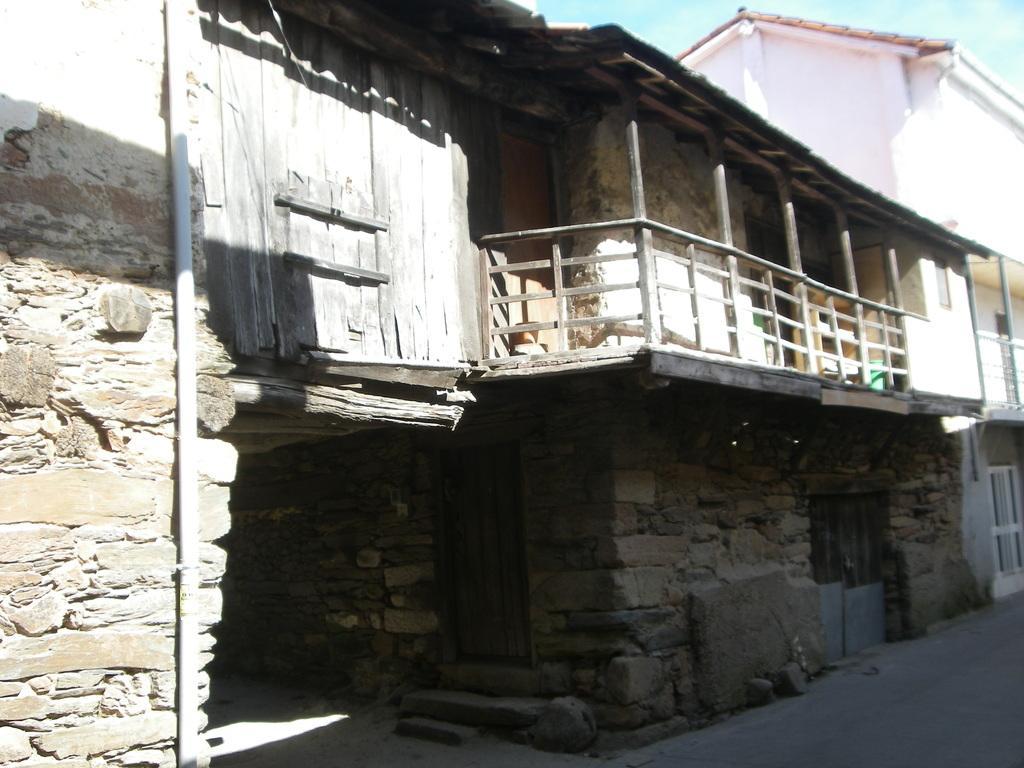How would you summarize this image in a sentence or two? In this image there is the sky, there is a building truncated towards the right of the image, there is the door, there are stairs, there is a wall truncated towards the left of the image, there is a pipe, there is a road. 